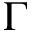Convert formula to latex. <formula><loc_0><loc_0><loc_500><loc_500>\Gamma</formula> 